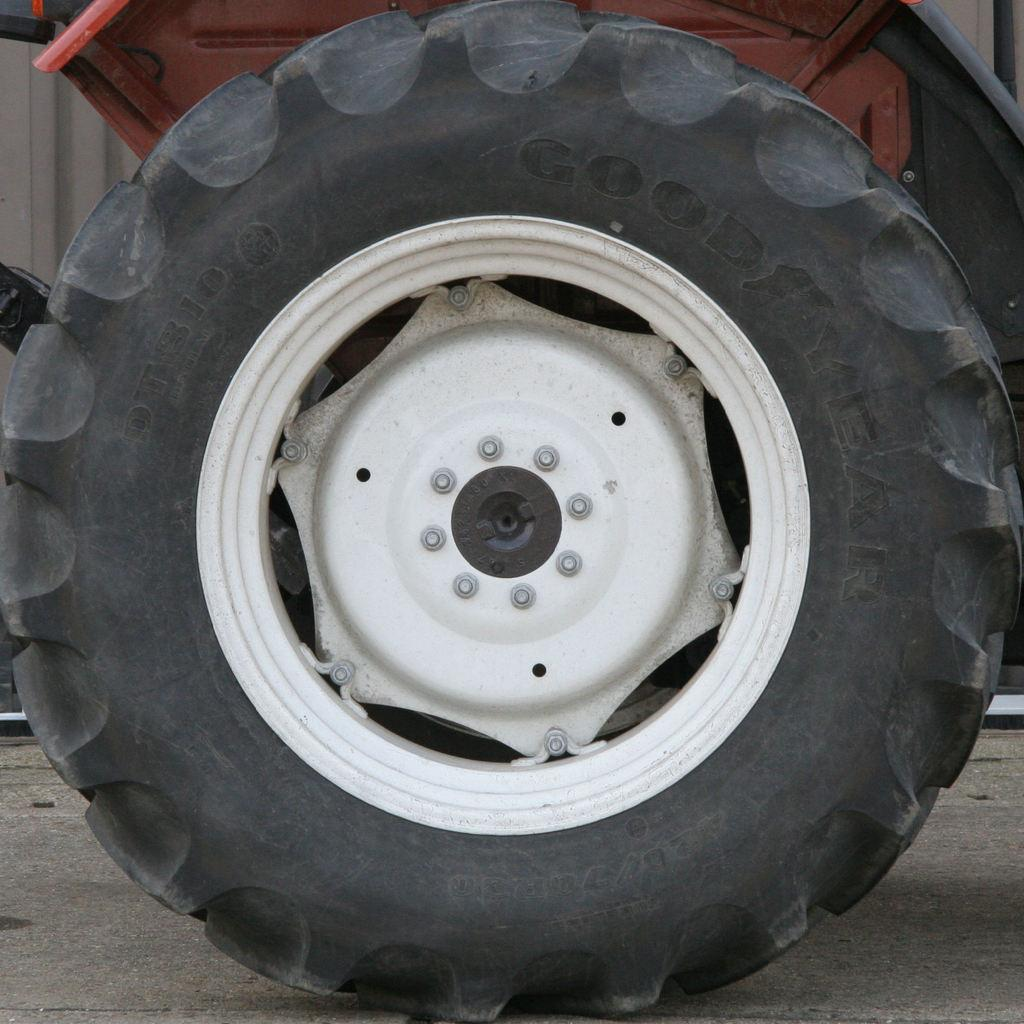What is the main object in the image? There is a wheel in the image. What is the wheel attached to? The wheel is fixed to a vehicle. What other parts of the wheel are visible in the image? There is a tire and a rim in the image. What type of surface is visible at the bottom of the image? The bottom of the image appears to be a road. Can you tell me how many grains of grain are visible in the image? There is no grain present in the image; it features a wheel, tire, rim, and a road. What type of guide is present in the image to help the vehicle navigate? There is no guide visible in the image; the vehicle's wheel, tire, and rim are the main focus. 